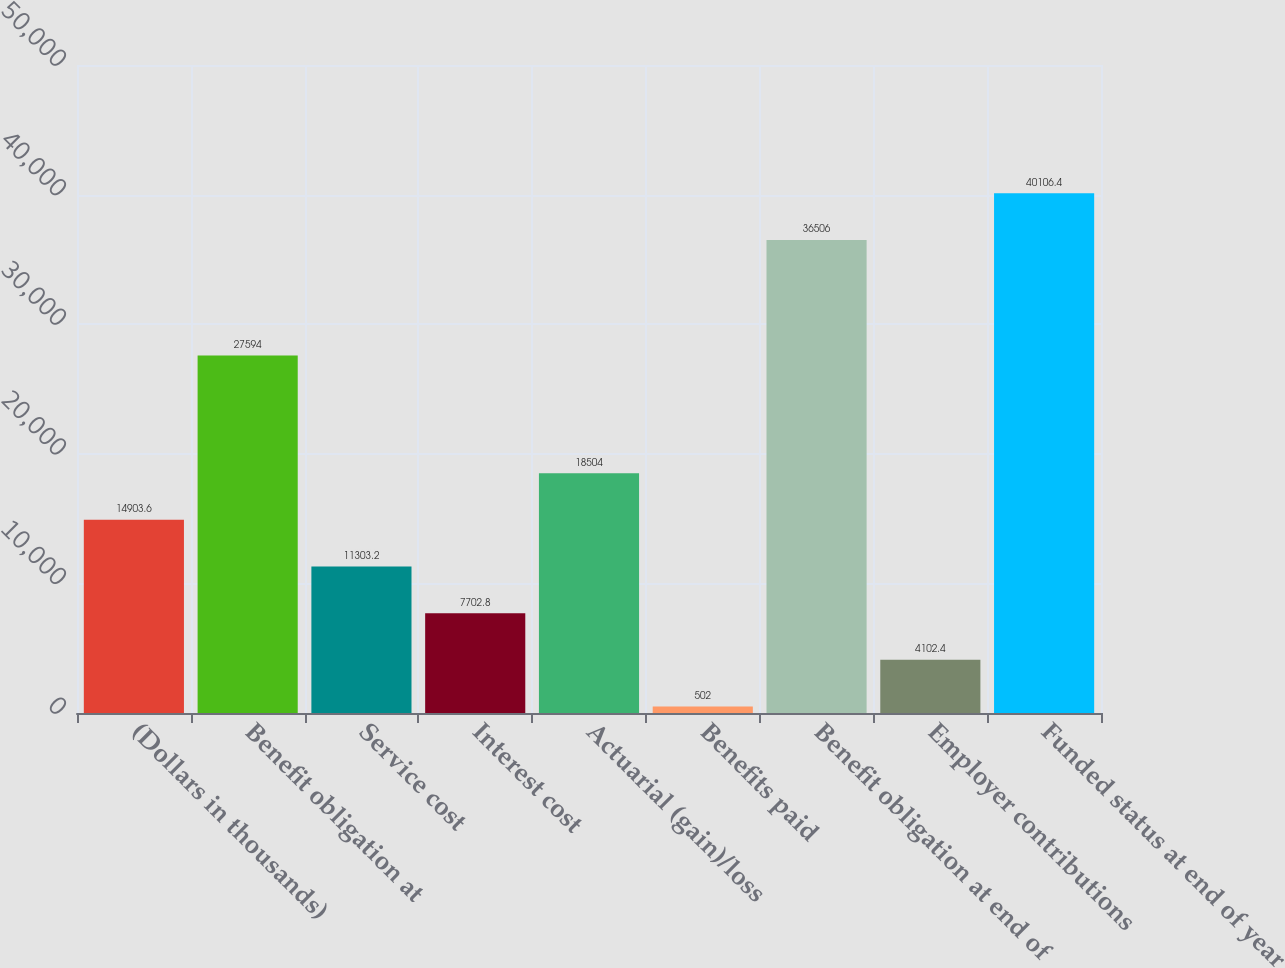<chart> <loc_0><loc_0><loc_500><loc_500><bar_chart><fcel>(Dollars in thousands)<fcel>Benefit obligation at<fcel>Service cost<fcel>Interest cost<fcel>Actuarial (gain)/loss<fcel>Benefits paid<fcel>Benefit obligation at end of<fcel>Employer contributions<fcel>Funded status at end of year<nl><fcel>14903.6<fcel>27594<fcel>11303.2<fcel>7702.8<fcel>18504<fcel>502<fcel>36506<fcel>4102.4<fcel>40106.4<nl></chart> 